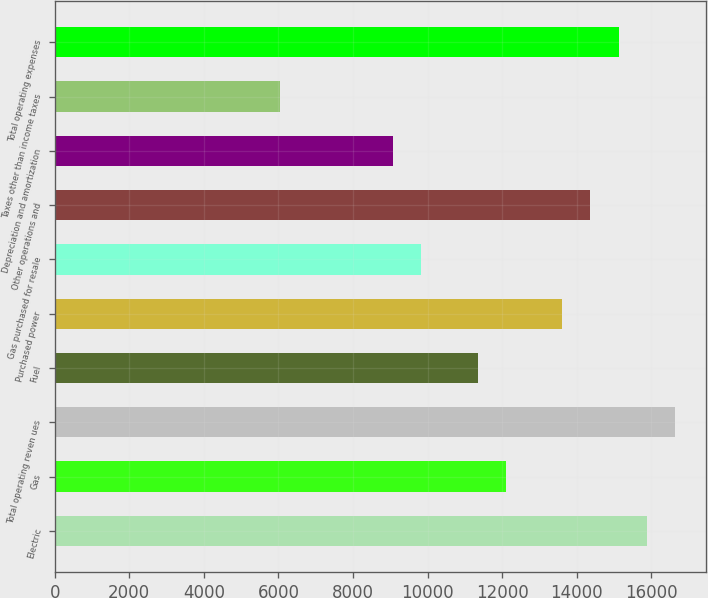Convert chart to OTSL. <chart><loc_0><loc_0><loc_500><loc_500><bar_chart><fcel>Electric<fcel>Gas<fcel>Total operating reven ues<fcel>Fuel<fcel>Purchased power<fcel>Gas purchased for resale<fcel>Other operations and<fcel>Depreciation and amortization<fcel>Taxes other than income taxes<fcel>Total operating expenses<nl><fcel>15877.5<fcel>12097.7<fcel>16633.4<fcel>11341.8<fcel>13609.6<fcel>9829.89<fcel>14365.6<fcel>9073.94<fcel>6050.14<fcel>15121.5<nl></chart> 